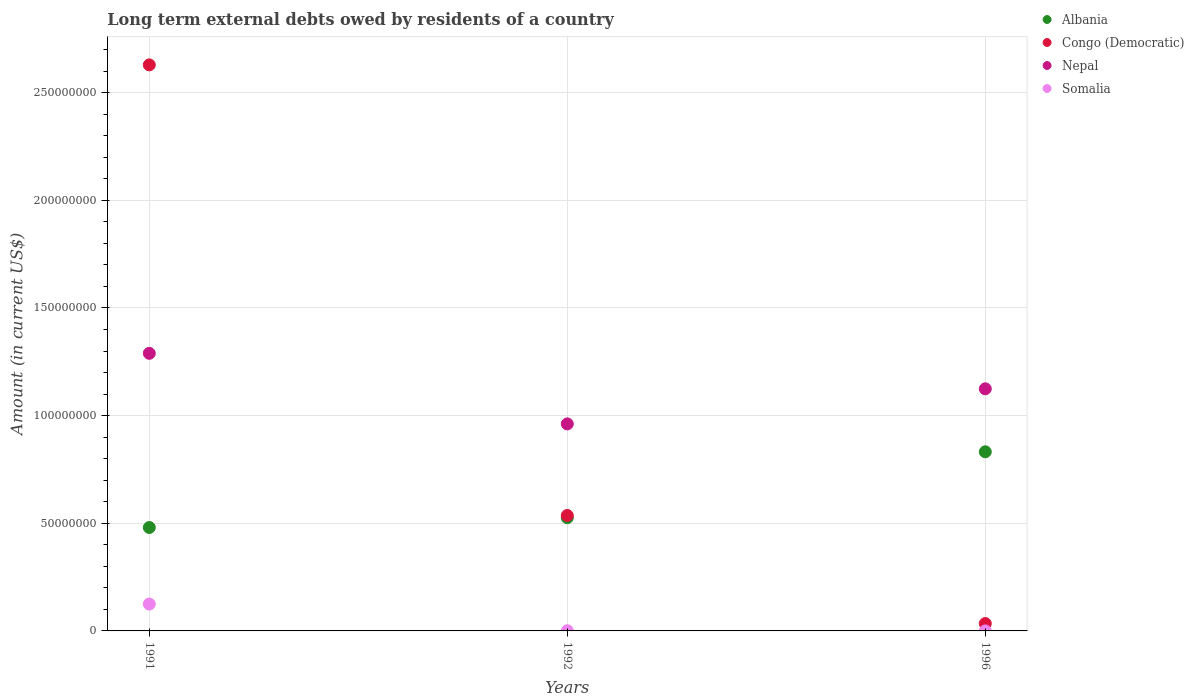What is the amount of long-term external debts owed by residents in Somalia in 1992?
Keep it short and to the point. 8.10e+04. Across all years, what is the maximum amount of long-term external debts owed by residents in Congo (Democratic)?
Ensure brevity in your answer.  2.63e+08. Across all years, what is the minimum amount of long-term external debts owed by residents in Nepal?
Keep it short and to the point. 9.62e+07. What is the total amount of long-term external debts owed by residents in Albania in the graph?
Give a very brief answer. 1.84e+08. What is the difference between the amount of long-term external debts owed by residents in Nepal in 1991 and that in 1996?
Your answer should be compact. 1.65e+07. What is the difference between the amount of long-term external debts owed by residents in Nepal in 1991 and the amount of long-term external debts owed by residents in Albania in 1992?
Offer a terse response. 7.64e+07. What is the average amount of long-term external debts owed by residents in Somalia per year?
Provide a succinct answer. 4.19e+06. In the year 1992, what is the difference between the amount of long-term external debts owed by residents in Somalia and amount of long-term external debts owed by residents in Nepal?
Ensure brevity in your answer.  -9.61e+07. In how many years, is the amount of long-term external debts owed by residents in Albania greater than 50000000 US$?
Keep it short and to the point. 2. What is the ratio of the amount of long-term external debts owed by residents in Nepal in 1992 to that in 1996?
Your response must be concise. 0.86. Is the amount of long-term external debts owed by residents in Nepal in 1992 less than that in 1996?
Ensure brevity in your answer.  Yes. Is the difference between the amount of long-term external debts owed by residents in Somalia in 1991 and 1996 greater than the difference between the amount of long-term external debts owed by residents in Nepal in 1991 and 1996?
Provide a short and direct response. No. What is the difference between the highest and the second highest amount of long-term external debts owed by residents in Albania?
Keep it short and to the point. 3.06e+07. What is the difference between the highest and the lowest amount of long-term external debts owed by residents in Nepal?
Offer a very short reply. 3.28e+07. In how many years, is the amount of long-term external debts owed by residents in Somalia greater than the average amount of long-term external debts owed by residents in Somalia taken over all years?
Make the answer very short. 1. Is the sum of the amount of long-term external debts owed by residents in Congo (Democratic) in 1991 and 1992 greater than the maximum amount of long-term external debts owed by residents in Albania across all years?
Your answer should be compact. Yes. Does the amount of long-term external debts owed by residents in Nepal monotonically increase over the years?
Provide a short and direct response. No. What is the difference between two consecutive major ticks on the Y-axis?
Provide a succinct answer. 5.00e+07. Are the values on the major ticks of Y-axis written in scientific E-notation?
Provide a succinct answer. No. What is the title of the graph?
Make the answer very short. Long term external debts owed by residents of a country. What is the label or title of the X-axis?
Your response must be concise. Years. What is the Amount (in current US$) of Albania in 1991?
Your response must be concise. 4.80e+07. What is the Amount (in current US$) in Congo (Democratic) in 1991?
Ensure brevity in your answer.  2.63e+08. What is the Amount (in current US$) in Nepal in 1991?
Your answer should be very brief. 1.29e+08. What is the Amount (in current US$) in Somalia in 1991?
Your answer should be very brief. 1.25e+07. What is the Amount (in current US$) of Albania in 1992?
Keep it short and to the point. 5.26e+07. What is the Amount (in current US$) of Congo (Democratic) in 1992?
Your answer should be compact. 5.36e+07. What is the Amount (in current US$) in Nepal in 1992?
Ensure brevity in your answer.  9.62e+07. What is the Amount (in current US$) in Somalia in 1992?
Keep it short and to the point. 8.10e+04. What is the Amount (in current US$) of Albania in 1996?
Ensure brevity in your answer.  8.32e+07. What is the Amount (in current US$) of Congo (Democratic) in 1996?
Offer a very short reply. 3.42e+06. What is the Amount (in current US$) in Nepal in 1996?
Your response must be concise. 1.12e+08. What is the Amount (in current US$) of Somalia in 1996?
Your answer should be compact. 1000. Across all years, what is the maximum Amount (in current US$) in Albania?
Give a very brief answer. 8.32e+07. Across all years, what is the maximum Amount (in current US$) of Congo (Democratic)?
Offer a terse response. 2.63e+08. Across all years, what is the maximum Amount (in current US$) of Nepal?
Make the answer very short. 1.29e+08. Across all years, what is the maximum Amount (in current US$) of Somalia?
Your answer should be compact. 1.25e+07. Across all years, what is the minimum Amount (in current US$) of Albania?
Your answer should be compact. 4.80e+07. Across all years, what is the minimum Amount (in current US$) in Congo (Democratic)?
Your answer should be compact. 3.42e+06. Across all years, what is the minimum Amount (in current US$) in Nepal?
Give a very brief answer. 9.62e+07. Across all years, what is the minimum Amount (in current US$) of Somalia?
Offer a terse response. 1000. What is the total Amount (in current US$) in Albania in the graph?
Your answer should be very brief. 1.84e+08. What is the total Amount (in current US$) of Congo (Democratic) in the graph?
Provide a succinct answer. 3.20e+08. What is the total Amount (in current US$) in Nepal in the graph?
Your response must be concise. 3.38e+08. What is the total Amount (in current US$) of Somalia in the graph?
Your answer should be very brief. 1.26e+07. What is the difference between the Amount (in current US$) of Albania in 1991 and that in 1992?
Offer a terse response. -4.53e+06. What is the difference between the Amount (in current US$) of Congo (Democratic) in 1991 and that in 1992?
Offer a terse response. 2.09e+08. What is the difference between the Amount (in current US$) in Nepal in 1991 and that in 1992?
Keep it short and to the point. 3.28e+07. What is the difference between the Amount (in current US$) of Somalia in 1991 and that in 1992?
Provide a succinct answer. 1.24e+07. What is the difference between the Amount (in current US$) of Albania in 1991 and that in 1996?
Ensure brevity in your answer.  -3.52e+07. What is the difference between the Amount (in current US$) of Congo (Democratic) in 1991 and that in 1996?
Make the answer very short. 2.59e+08. What is the difference between the Amount (in current US$) in Nepal in 1991 and that in 1996?
Offer a terse response. 1.65e+07. What is the difference between the Amount (in current US$) of Somalia in 1991 and that in 1996?
Provide a short and direct response. 1.25e+07. What is the difference between the Amount (in current US$) of Albania in 1992 and that in 1996?
Offer a terse response. -3.06e+07. What is the difference between the Amount (in current US$) of Congo (Democratic) in 1992 and that in 1996?
Your answer should be compact. 5.02e+07. What is the difference between the Amount (in current US$) in Nepal in 1992 and that in 1996?
Make the answer very short. -1.63e+07. What is the difference between the Amount (in current US$) in Somalia in 1992 and that in 1996?
Give a very brief answer. 8.00e+04. What is the difference between the Amount (in current US$) of Albania in 1991 and the Amount (in current US$) of Congo (Democratic) in 1992?
Give a very brief answer. -5.59e+06. What is the difference between the Amount (in current US$) of Albania in 1991 and the Amount (in current US$) of Nepal in 1992?
Ensure brevity in your answer.  -4.81e+07. What is the difference between the Amount (in current US$) in Albania in 1991 and the Amount (in current US$) in Somalia in 1992?
Ensure brevity in your answer.  4.80e+07. What is the difference between the Amount (in current US$) of Congo (Democratic) in 1991 and the Amount (in current US$) of Nepal in 1992?
Your answer should be compact. 1.67e+08. What is the difference between the Amount (in current US$) of Congo (Democratic) in 1991 and the Amount (in current US$) of Somalia in 1992?
Your answer should be very brief. 2.63e+08. What is the difference between the Amount (in current US$) of Nepal in 1991 and the Amount (in current US$) of Somalia in 1992?
Make the answer very short. 1.29e+08. What is the difference between the Amount (in current US$) in Albania in 1991 and the Amount (in current US$) in Congo (Democratic) in 1996?
Ensure brevity in your answer.  4.46e+07. What is the difference between the Amount (in current US$) of Albania in 1991 and the Amount (in current US$) of Nepal in 1996?
Your answer should be very brief. -6.44e+07. What is the difference between the Amount (in current US$) of Albania in 1991 and the Amount (in current US$) of Somalia in 1996?
Your answer should be very brief. 4.80e+07. What is the difference between the Amount (in current US$) of Congo (Democratic) in 1991 and the Amount (in current US$) of Nepal in 1996?
Give a very brief answer. 1.50e+08. What is the difference between the Amount (in current US$) of Congo (Democratic) in 1991 and the Amount (in current US$) of Somalia in 1996?
Your answer should be compact. 2.63e+08. What is the difference between the Amount (in current US$) in Nepal in 1991 and the Amount (in current US$) in Somalia in 1996?
Your answer should be very brief. 1.29e+08. What is the difference between the Amount (in current US$) in Albania in 1992 and the Amount (in current US$) in Congo (Democratic) in 1996?
Ensure brevity in your answer.  4.91e+07. What is the difference between the Amount (in current US$) in Albania in 1992 and the Amount (in current US$) in Nepal in 1996?
Make the answer very short. -5.99e+07. What is the difference between the Amount (in current US$) of Albania in 1992 and the Amount (in current US$) of Somalia in 1996?
Ensure brevity in your answer.  5.26e+07. What is the difference between the Amount (in current US$) in Congo (Democratic) in 1992 and the Amount (in current US$) in Nepal in 1996?
Your answer should be very brief. -5.88e+07. What is the difference between the Amount (in current US$) in Congo (Democratic) in 1992 and the Amount (in current US$) in Somalia in 1996?
Ensure brevity in your answer.  5.36e+07. What is the difference between the Amount (in current US$) of Nepal in 1992 and the Amount (in current US$) of Somalia in 1996?
Provide a short and direct response. 9.61e+07. What is the average Amount (in current US$) of Albania per year?
Give a very brief answer. 6.13e+07. What is the average Amount (in current US$) of Congo (Democratic) per year?
Ensure brevity in your answer.  1.07e+08. What is the average Amount (in current US$) in Nepal per year?
Your answer should be very brief. 1.13e+08. What is the average Amount (in current US$) in Somalia per year?
Your response must be concise. 4.19e+06. In the year 1991, what is the difference between the Amount (in current US$) of Albania and Amount (in current US$) of Congo (Democratic)?
Offer a terse response. -2.15e+08. In the year 1991, what is the difference between the Amount (in current US$) of Albania and Amount (in current US$) of Nepal?
Your answer should be very brief. -8.09e+07. In the year 1991, what is the difference between the Amount (in current US$) in Albania and Amount (in current US$) in Somalia?
Make the answer very short. 3.56e+07. In the year 1991, what is the difference between the Amount (in current US$) of Congo (Democratic) and Amount (in current US$) of Nepal?
Ensure brevity in your answer.  1.34e+08. In the year 1991, what is the difference between the Amount (in current US$) of Congo (Democratic) and Amount (in current US$) of Somalia?
Offer a very short reply. 2.50e+08. In the year 1991, what is the difference between the Amount (in current US$) in Nepal and Amount (in current US$) in Somalia?
Give a very brief answer. 1.16e+08. In the year 1992, what is the difference between the Amount (in current US$) in Albania and Amount (in current US$) in Congo (Democratic)?
Make the answer very short. -1.06e+06. In the year 1992, what is the difference between the Amount (in current US$) in Albania and Amount (in current US$) in Nepal?
Offer a terse response. -4.36e+07. In the year 1992, what is the difference between the Amount (in current US$) in Albania and Amount (in current US$) in Somalia?
Your answer should be very brief. 5.25e+07. In the year 1992, what is the difference between the Amount (in current US$) of Congo (Democratic) and Amount (in current US$) of Nepal?
Your response must be concise. -4.25e+07. In the year 1992, what is the difference between the Amount (in current US$) of Congo (Democratic) and Amount (in current US$) of Somalia?
Your response must be concise. 5.35e+07. In the year 1992, what is the difference between the Amount (in current US$) of Nepal and Amount (in current US$) of Somalia?
Give a very brief answer. 9.61e+07. In the year 1996, what is the difference between the Amount (in current US$) in Albania and Amount (in current US$) in Congo (Democratic)?
Give a very brief answer. 7.98e+07. In the year 1996, what is the difference between the Amount (in current US$) of Albania and Amount (in current US$) of Nepal?
Offer a terse response. -2.92e+07. In the year 1996, what is the difference between the Amount (in current US$) of Albania and Amount (in current US$) of Somalia?
Your answer should be very brief. 8.32e+07. In the year 1996, what is the difference between the Amount (in current US$) in Congo (Democratic) and Amount (in current US$) in Nepal?
Your answer should be compact. -1.09e+08. In the year 1996, what is the difference between the Amount (in current US$) in Congo (Democratic) and Amount (in current US$) in Somalia?
Your response must be concise. 3.42e+06. In the year 1996, what is the difference between the Amount (in current US$) of Nepal and Amount (in current US$) of Somalia?
Your response must be concise. 1.12e+08. What is the ratio of the Amount (in current US$) in Albania in 1991 to that in 1992?
Provide a short and direct response. 0.91. What is the ratio of the Amount (in current US$) in Congo (Democratic) in 1991 to that in 1992?
Your answer should be compact. 4.9. What is the ratio of the Amount (in current US$) of Nepal in 1991 to that in 1992?
Offer a terse response. 1.34. What is the ratio of the Amount (in current US$) of Somalia in 1991 to that in 1992?
Make the answer very short. 154.01. What is the ratio of the Amount (in current US$) of Albania in 1991 to that in 1996?
Your answer should be compact. 0.58. What is the ratio of the Amount (in current US$) of Congo (Democratic) in 1991 to that in 1996?
Make the answer very short. 76.76. What is the ratio of the Amount (in current US$) in Nepal in 1991 to that in 1996?
Give a very brief answer. 1.15. What is the ratio of the Amount (in current US$) of Somalia in 1991 to that in 1996?
Your answer should be very brief. 1.25e+04. What is the ratio of the Amount (in current US$) of Albania in 1992 to that in 1996?
Your response must be concise. 0.63. What is the ratio of the Amount (in current US$) of Congo (Democratic) in 1992 to that in 1996?
Your answer should be compact. 15.66. What is the ratio of the Amount (in current US$) of Nepal in 1992 to that in 1996?
Keep it short and to the point. 0.86. What is the ratio of the Amount (in current US$) in Somalia in 1992 to that in 1996?
Offer a very short reply. 81. What is the difference between the highest and the second highest Amount (in current US$) in Albania?
Offer a terse response. 3.06e+07. What is the difference between the highest and the second highest Amount (in current US$) in Congo (Democratic)?
Give a very brief answer. 2.09e+08. What is the difference between the highest and the second highest Amount (in current US$) of Nepal?
Make the answer very short. 1.65e+07. What is the difference between the highest and the second highest Amount (in current US$) of Somalia?
Make the answer very short. 1.24e+07. What is the difference between the highest and the lowest Amount (in current US$) of Albania?
Ensure brevity in your answer.  3.52e+07. What is the difference between the highest and the lowest Amount (in current US$) of Congo (Democratic)?
Keep it short and to the point. 2.59e+08. What is the difference between the highest and the lowest Amount (in current US$) in Nepal?
Keep it short and to the point. 3.28e+07. What is the difference between the highest and the lowest Amount (in current US$) of Somalia?
Make the answer very short. 1.25e+07. 